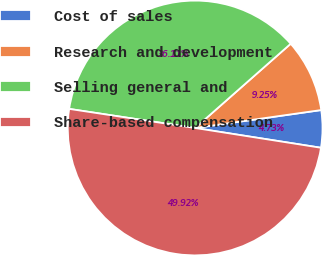<chart> <loc_0><loc_0><loc_500><loc_500><pie_chart><fcel>Cost of sales<fcel>Research and development<fcel>Selling general and<fcel>Share-based compensation<nl><fcel>4.73%<fcel>9.25%<fcel>36.11%<fcel>49.92%<nl></chart> 